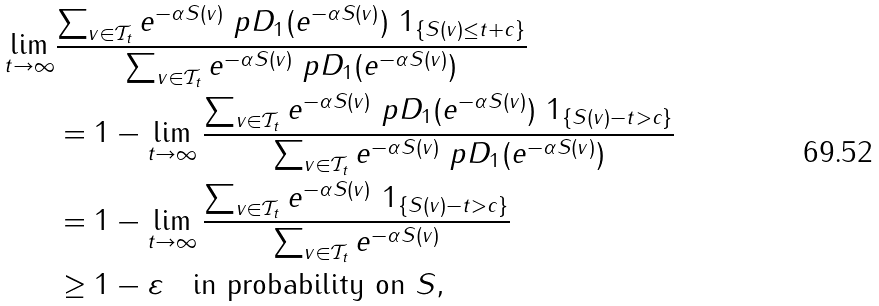Convert formula to latex. <formula><loc_0><loc_0><loc_500><loc_500>\lim _ { t \to \infty } & \frac { \sum _ { v \in \mathcal { T } _ { t } } e ^ { - \alpha S ( v ) } \ p D _ { 1 } ( e ^ { - \alpha S ( v ) } ) \ 1 _ { \{ S ( v ) \leq t + c \} } } { \sum _ { v \in \mathcal { T } _ { t } } e ^ { - \alpha S ( v ) } \ p D _ { 1 } ( e ^ { - \alpha S ( v ) } ) } \\ & = 1 - \lim _ { t \to \infty } \frac { \sum _ { v \in \mathcal { T } _ { t } } e ^ { - \alpha S ( v ) } \ p D _ { 1 } ( e ^ { - \alpha S ( v ) } ) \ 1 _ { \{ S ( v ) - t > c \} } } { \sum _ { v \in \mathcal { T } _ { t } } e ^ { - \alpha S ( v ) } \ p D _ { 1 } ( e ^ { - \alpha S ( v ) } ) } \\ & = 1 - \lim _ { t \to \infty } \frac { \sum _ { v \in \mathcal { T } _ { t } } e ^ { - \alpha S ( v ) } \ 1 _ { \{ S ( v ) - t > c \} } } { \sum _ { v \in \mathcal { T } _ { t } } e ^ { - \alpha S ( v ) } } \\ & \geq 1 - \varepsilon \quad \text {in probability on } S ,</formula> 